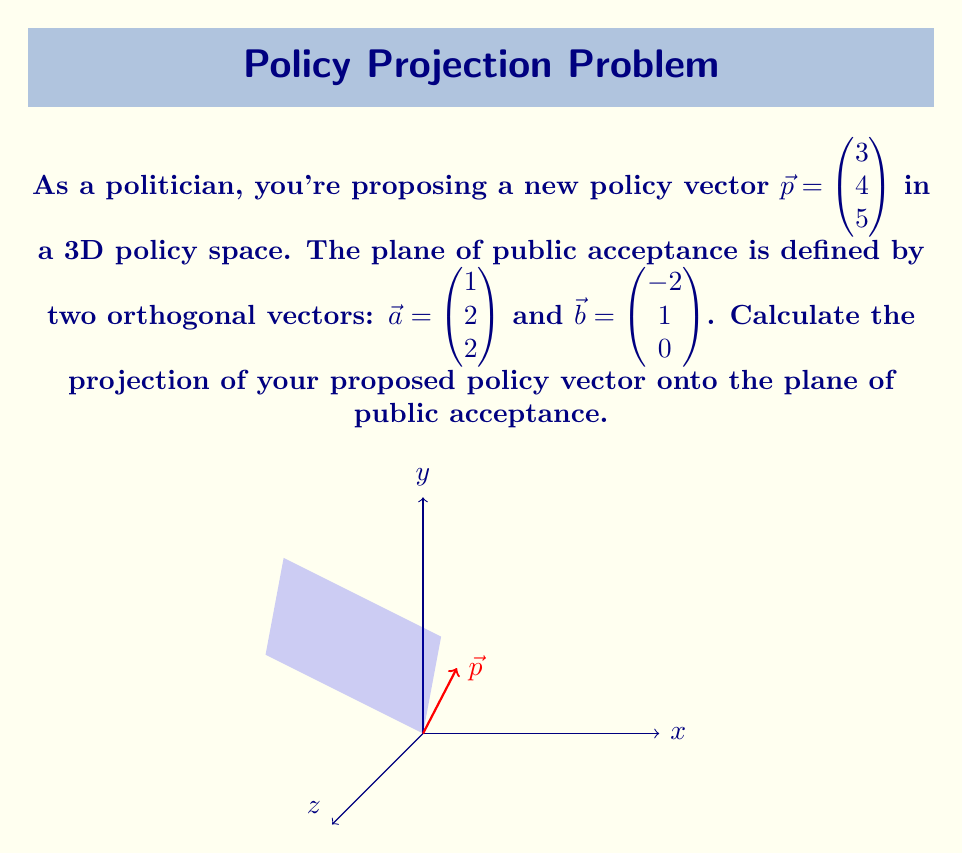What is the answer to this math problem? To project the policy vector $\vec{p}$ onto the plane defined by vectors $\vec{a}$ and $\vec{b}$, we need to follow these steps:

1) First, we need to find the normal vector to the plane. We can do this by calculating the cross product of $\vec{a}$ and $\vec{b}$:

   $\vec{n} = \vec{a} \times \vec{b} = \begin{vmatrix} 
   \hat{i} & \hat{j} & \hat{k} \\
   1 & 2 & 2 \\
   -2 & 1 & 0
   \end{vmatrix} = (2-2)\hat{i} - (0-(-4))\hat{j} + (1-4)\hat{k} = \begin{pmatrix} 0 \\ 4 \\ -3 \end{pmatrix}$

2) Now, we can calculate the projection of $\vec{p}$ onto $\vec{n}$:

   $\text{proj}_{\vec{n}}\vec{p} = \frac{\vec{p} \cdot \vec{n}}{\|\vec{n}\|^2} \vec{n}$

3) Calculate $\vec{p} \cdot \vec{n}$:
   
   $\vec{p} \cdot \vec{n} = 3(0) + 4(4) + 5(-3) = 16 - 15 = 1$

4) Calculate $\|\vec{n}\|^2$:
   
   $\|\vec{n}\|^2 = 0^2 + 4^2 + (-3)^2 = 16 + 9 = 25$

5) Therefore, the projection of $\vec{p}$ onto $\vec{n}$ is:

   $\text{proj}_{\vec{n}}\vec{p} = \frac{1}{25} \begin{pmatrix} 0 \\ 4 \\ -3 \end{pmatrix} = \begin{pmatrix} 0 \\ 4/25 \\ -3/25 \end{pmatrix}$

6) The projection of $\vec{p}$ onto the plane is the difference between $\vec{p}$ and its projection onto $\vec{n}$:

   $\text{proj}_{\text{plane}}\vec{p} = \vec{p} - \text{proj}_{\vec{n}}\vec{p} = \begin{pmatrix} 3 \\ 4 \\ 5 \end{pmatrix} - \begin{pmatrix} 0 \\ 4/25 \\ -3/25 \end{pmatrix} = \begin{pmatrix} 3 \\ 96/25 \\ 128/25 \end{pmatrix}$
Answer: $\begin{pmatrix} 3 \\ 96/25 \\ 128/25 \end{pmatrix}$ 